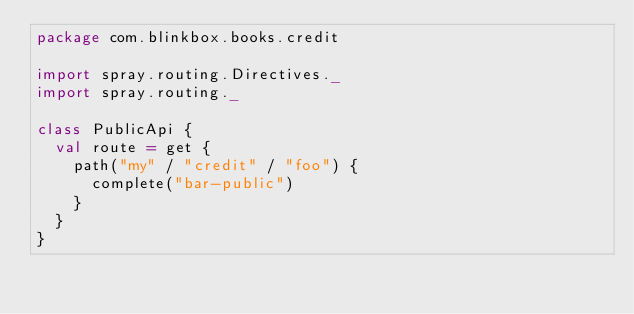<code> <loc_0><loc_0><loc_500><loc_500><_Scala_>package com.blinkbox.books.credit

import spray.routing.Directives._
import spray.routing._

class PublicApi {
  val route = get {
    path("my" / "credit" / "foo") {
      complete("bar-public")
    }
  }
}
</code> 